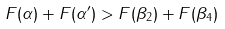<formula> <loc_0><loc_0><loc_500><loc_500>F ( \alpha ) + F ( \alpha ^ { \prime } ) > F ( \beta _ { 2 } ) + F ( \beta _ { 4 } )</formula> 